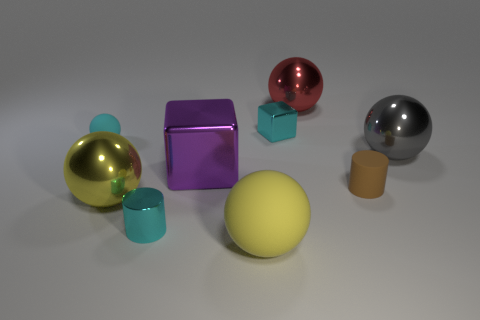There is a large red shiny thing; are there any small cyan blocks left of it?
Offer a terse response. Yes. What is the color of the tiny object that is on the right side of the purple shiny block and in front of the cyan block?
Offer a terse response. Brown. Are there any cylinders of the same color as the tiny shiny cube?
Your answer should be very brief. Yes. Is the large ball left of the large matte object made of the same material as the small cylinder to the left of the large matte object?
Keep it short and to the point. Yes. What is the size of the shiny ball on the right side of the large red object?
Give a very brief answer. Large. The cyan ball has what size?
Offer a terse response. Small. There is a cyan object in front of the big object that is on the left side of the small cylinder that is left of the red sphere; what is its size?
Provide a succinct answer. Small. Is there a tiny red cylinder made of the same material as the brown object?
Your answer should be compact. No. There is a yellow shiny object; what shape is it?
Your answer should be very brief. Sphere. There is a tiny ball that is made of the same material as the tiny brown thing; what is its color?
Make the answer very short. Cyan. 